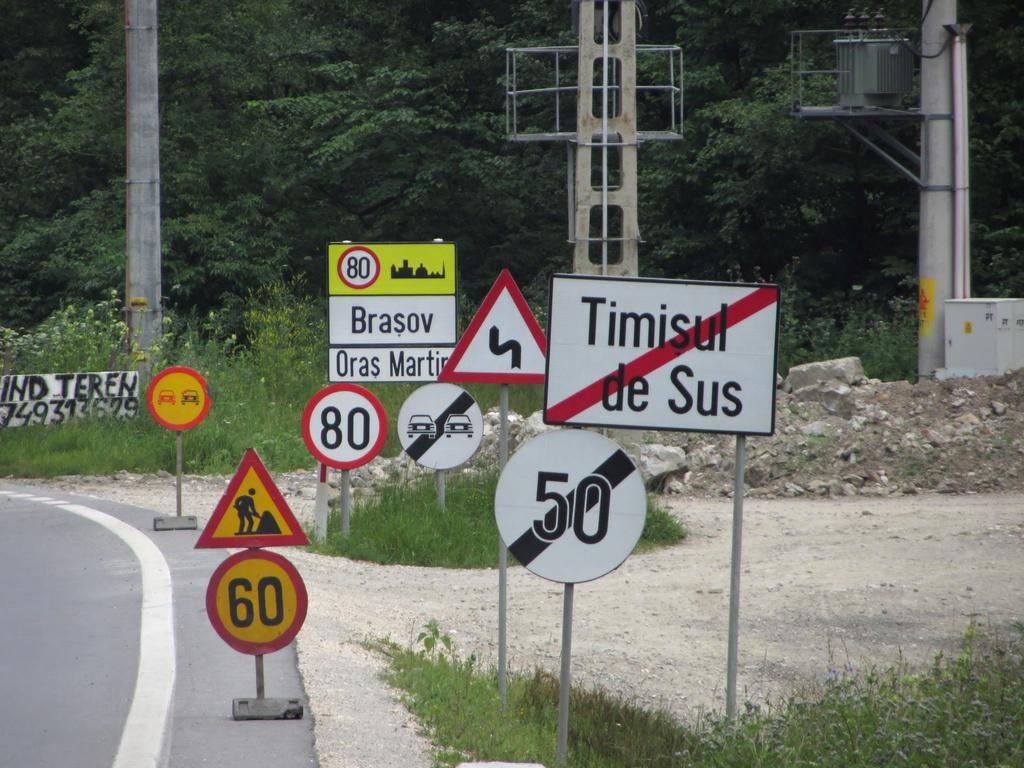<image>
Render a clear and concise summary of the photo. A sign that says "Timisul de Sus" has a red diagonal line through it. 